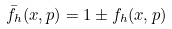Convert formula to latex. <formula><loc_0><loc_0><loc_500><loc_500>\bar { f } _ { h } ( x , p ) = 1 \pm f _ { h } ( x , p )</formula> 